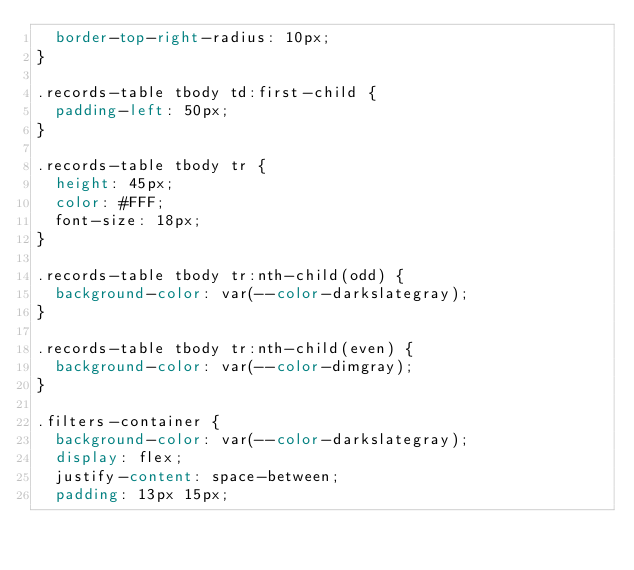<code> <loc_0><loc_0><loc_500><loc_500><_CSS_>  border-top-right-radius: 10px;
}

.records-table tbody td:first-child {
  padding-left: 50px;
}

.records-table tbody tr {
  height: 45px;
  color: #FFF;
  font-size: 18px;
}

.records-table tbody tr:nth-child(odd) {
  background-color: var(--color-darkslategray);
}

.records-table tbody tr:nth-child(even) {
  background-color: var(--color-dimgray);
}

.filters-container {
  background-color: var(--color-darkslategray);
  display: flex;
  justify-content: space-between;
  padding: 13px 15px;</code> 